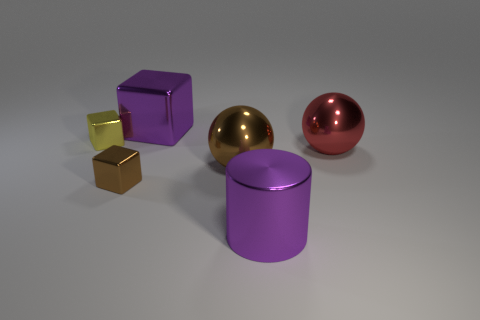Add 3 gray cylinders. How many objects exist? 9 Subtract all cylinders. How many objects are left? 5 Add 6 metal spheres. How many metal spheres exist? 8 Subtract 0 brown cylinders. How many objects are left? 6 Subtract all brown spheres. Subtract all large red shiny spheres. How many objects are left? 4 Add 3 large purple shiny cubes. How many large purple shiny cubes are left? 4 